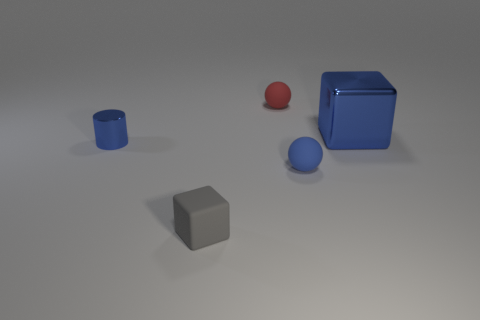Add 3 tiny balls. How many objects exist? 8 Subtract all cubes. How many objects are left? 3 Add 1 small gray things. How many small gray things are left? 2 Add 3 tiny matte blocks. How many tiny matte blocks exist? 4 Subtract 0 yellow balls. How many objects are left? 5 Subtract all red rubber things. Subtract all tiny brown shiny cylinders. How many objects are left? 4 